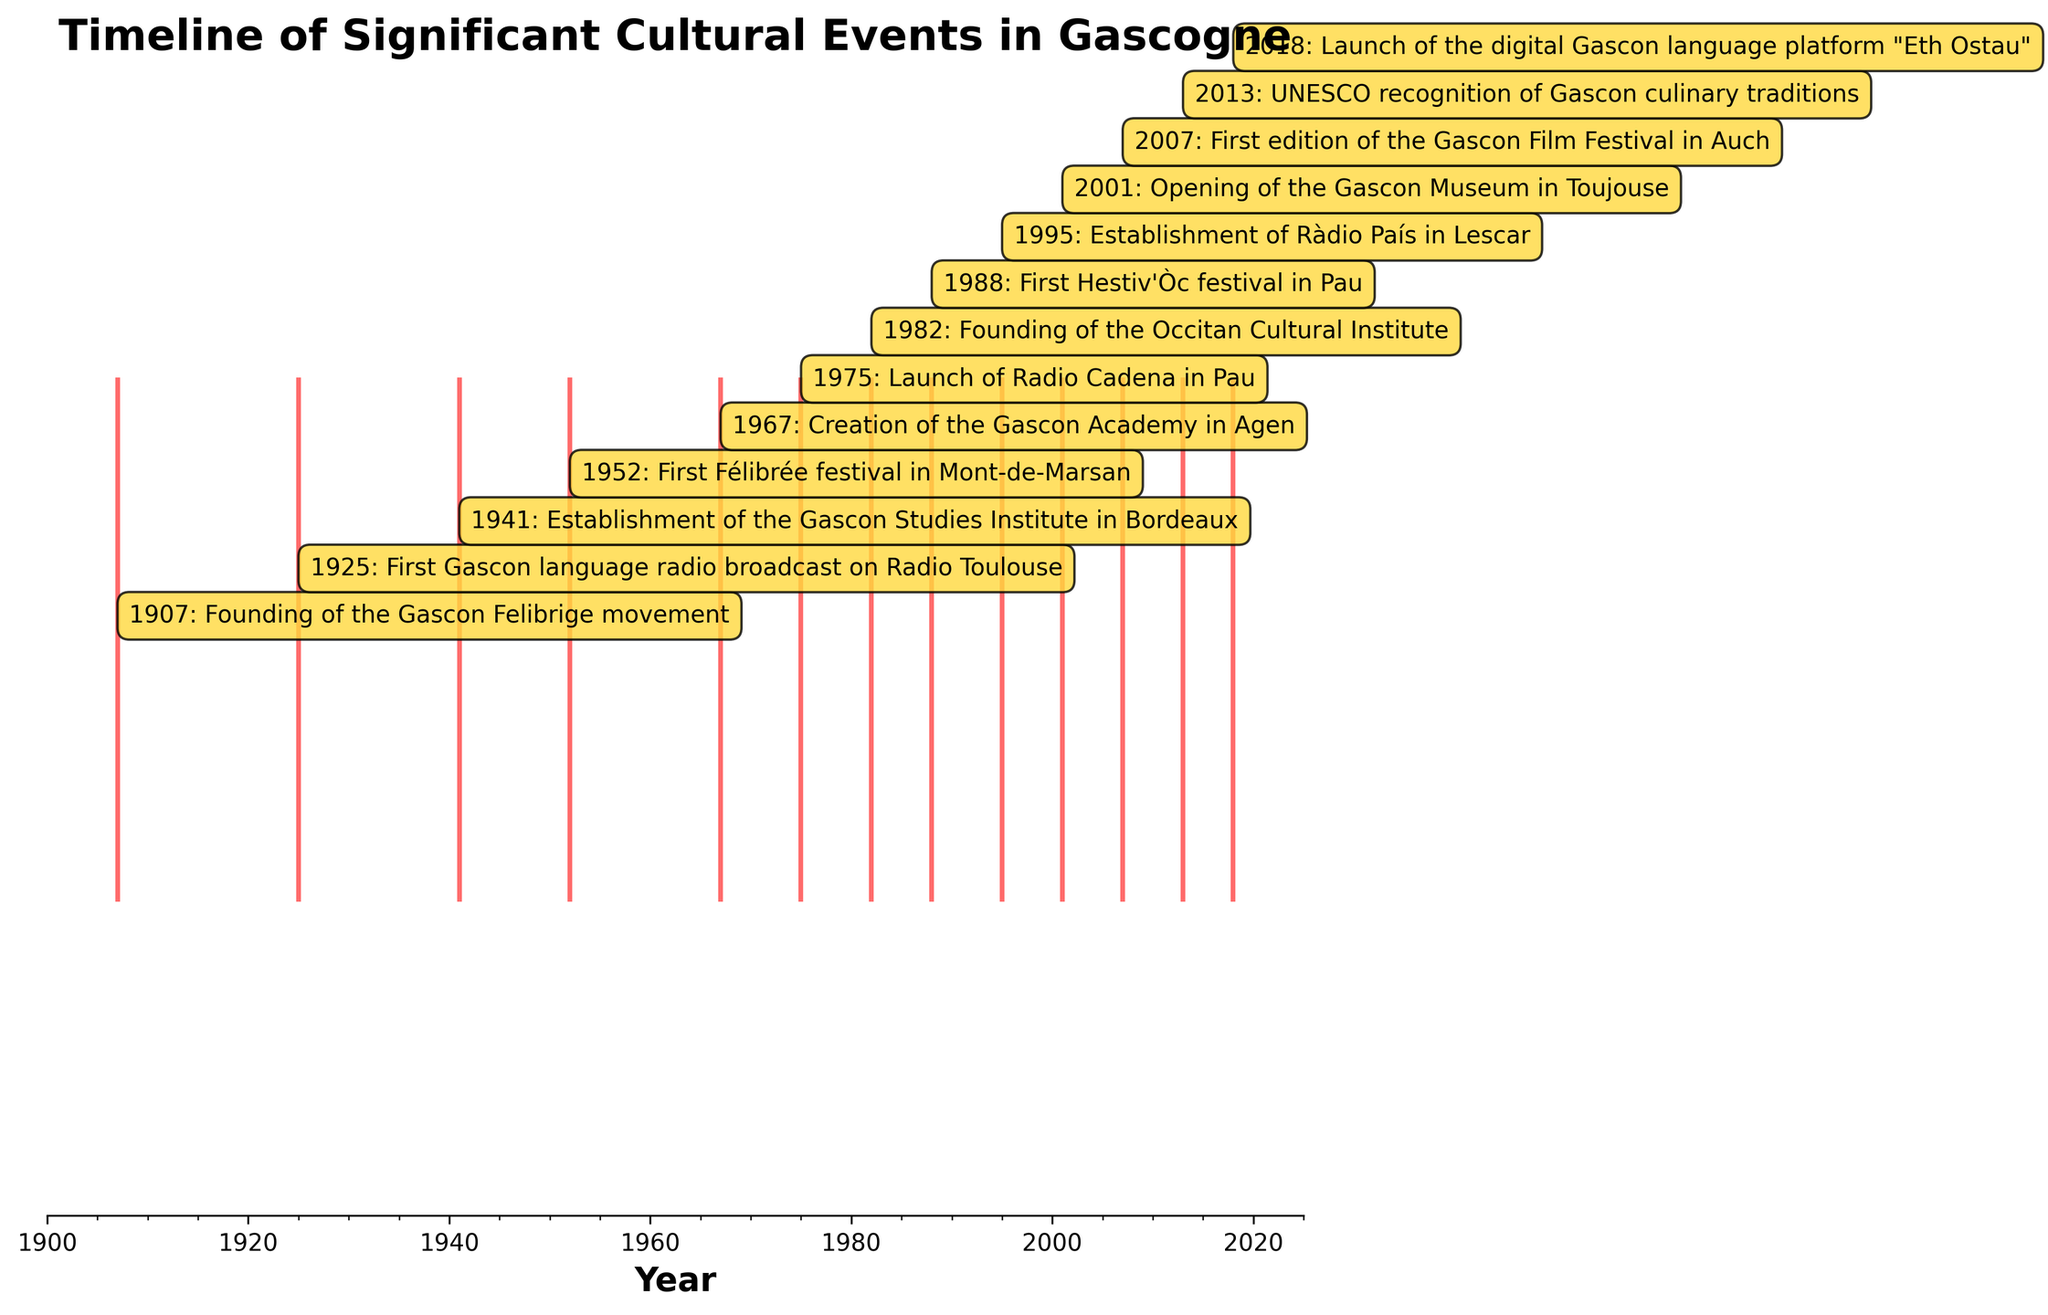What's the title of the figure? The title is displayed at the top of the figure.
Answer: Timeline of Significant Cultural Events in Gascogne How many significant cultural events are depicted in the figure? Each event is represented by a line. Counting all the lines will give the number of events.
Answer: 13 What's the earliest event shown in the figure? The earliest event is the one closest to the left end of the timeline. It is annotated with the year and event description.
Answer: Founding of the Gascon Felibrige movement (1907) Which year features the launch of Radio Cadena in Pau? Look along the timeline for the annotation stating "Launch of Radio Cadena in Pau." The annotated year next to it will be the answer.
Answer: 1975 What is the time span covered by the events in the figure? The figure spans from the earliest event's year to the latest event's year. Here, from 1907 to 2018.
Answer: 111 years How many events occurred between 1940 and 2000? Identify the events that fall within the given range by their years, and count them.
Answer: 7 Compare the number of events in the first half of the 20th century (1900-1950) with the second half (1951-2000). Which period had more events? Count the events occurring in each half-century period and compare the totals.
Answer: Second half (1951-2000) What year was the Gascon Academy in Agen created? Look for the annotation stating "Creation of the Gascon Academy in Agen." The annotated year next to it will be the answer.
Answer: 1967 What proportion of the events occurred after 1980? Determine the number of events post-1980 and divide it by the total number of events to find the proportion. Since events after 1980 are 7 and the total is 13, the calculation is 7/13.
Answer: 0.54 Describe the most recent cultural event in Gascogne shown in the figure. Identify the annotation closest to the right end of the timeline, which represents the most recent event.
Answer: Launch of the digital Gascon language platform "Eth Ostau" (2018) 